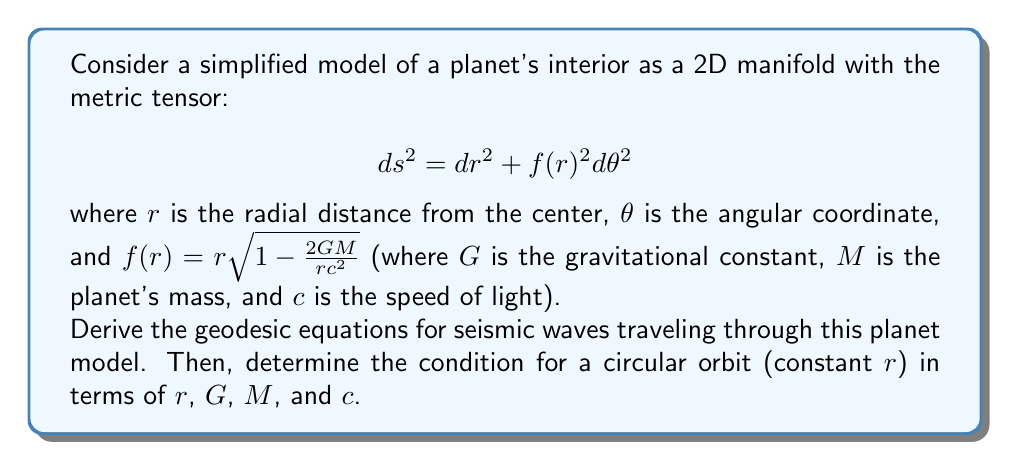Teach me how to tackle this problem. To solve this problem, we'll follow these steps:

1) First, we need to derive the Christoffel symbols for this metric.
2) Then, we'll use these to write out the geodesic equations.
3) Finally, we'll consider the condition for a circular orbit.

Step 1: Deriving the Christoffel symbols

The non-zero components of the metric tensor are:
$$ g_{rr} = 1, \quad g_{\theta\theta} = f(r)^2 $$

The non-zero Christoffel symbols are:

$$ \Gamma^r_{\theta\theta} = -f(r)f'(r) $$
$$ \Gamma^\theta_{r\theta} = \Gamma^\theta_{\theta r} = \frac{f'(r)}{f(r)} $$

Where $f'(r) = \frac{d}{dr}f(r) = \sqrt{1-\frac{2GM}{rc^2}} + \frac{r}{2}\left(-\frac{2GM}{r^2c^2}\right)\left(1-\frac{2GM}{rc^2}\right)^{-1/2}$

Step 2: Writing the geodesic equations

The geodesic equations are:

$$ \frac{d^2x^\mu}{ds^2} + \Gamma^\mu_{\alpha\beta}\frac{dx^\alpha}{ds}\frac{dx^\beta}{ds} = 0 $$

For our metric, these become:

$$ \frac{d^2r}{ds^2} - f(r)f'(r)\left(\frac{d\theta}{ds}\right)^2 = 0 $$
$$ \frac{d^2\theta}{ds^2} + \frac{2f'(r)}{f(r)}\frac{dr}{ds}\frac{d\theta}{ds} = 0 $$

Step 3: Condition for circular orbit

For a circular orbit, $r$ is constant, so $\frac{dr}{ds} = 0$ and $\frac{d^2r}{ds^2} = 0$. 

Substituting these into the first geodesic equation:

$$ 0 = f(r)f'(r)\left(\frac{d\theta}{ds}\right)^2 $$

For this to be true (assuming non-zero angular velocity), we must have:

$$ f(r)f'(r) = 0 $$

Substituting the expression for $f(r)$:

$$ r\sqrt{1-\frac{2GM}{rc^2}} \cdot \left(\sqrt{1-\frac{2GM}{rc^2}} + \frac{r}{2}\left(-\frac{2GM}{r^2c^2}\right)\left(1-\frac{2GM}{rc^2}\right)^{-1/2}\right) = 0 $$

Simplifying:

$$ r\left(1-\frac{2GM}{rc^2}\right) - \frac{GM}{c^2} = 0 $$

$$ r - \frac{2GM}{c^2} - \frac{GM}{c^2} = 0 $$

$$ r = \frac{3GM}{c^2} $$

This is the condition for a circular orbit in terms of $r$, $G$, $M$, and $c$.
Answer: The geodesic equations for seismic waves in this planet model are:

$$ \frac{d^2r}{ds^2} - f(r)f'(r)\left(\frac{d\theta}{ds}\right)^2 = 0 $$
$$ \frac{d^2\theta}{ds^2} + \frac{2f'(r)}{f(r)}\frac{dr}{ds}\frac{d\theta}{ds} = 0 $$

The condition for a circular orbit is:

$$ r = \frac{3GM}{c^2} $$ 